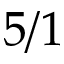<formula> <loc_0><loc_0><loc_500><loc_500>5 / 1</formula> 